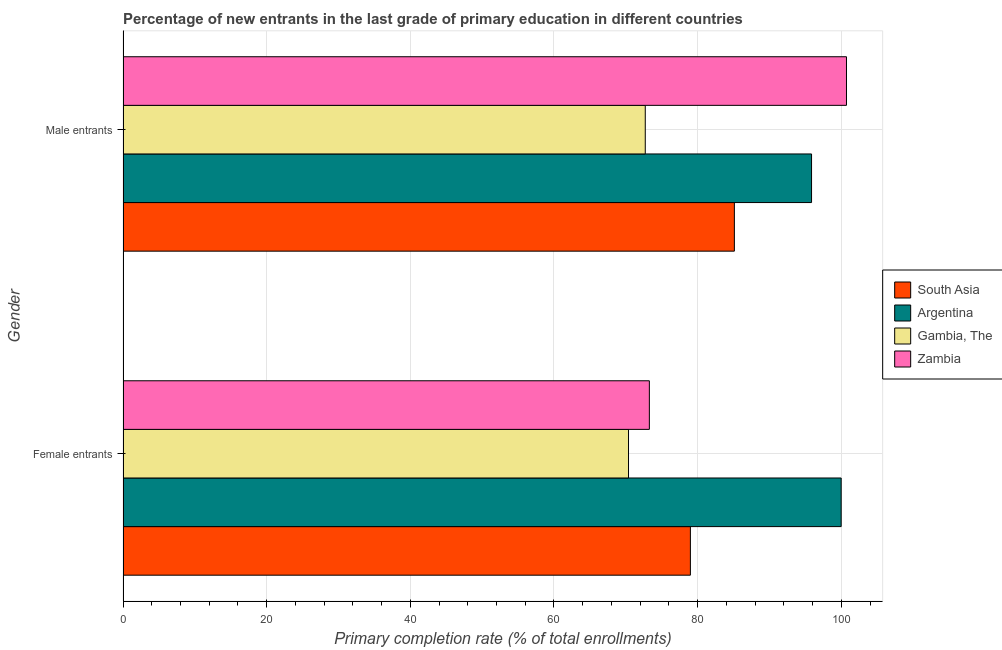How many different coloured bars are there?
Your answer should be compact. 4. How many bars are there on the 2nd tick from the top?
Provide a short and direct response. 4. How many bars are there on the 2nd tick from the bottom?
Give a very brief answer. 4. What is the label of the 1st group of bars from the top?
Your answer should be very brief. Male entrants. What is the primary completion rate of male entrants in South Asia?
Your answer should be very brief. 85.12. Across all countries, what is the maximum primary completion rate of female entrants?
Provide a succinct answer. 99.98. Across all countries, what is the minimum primary completion rate of male entrants?
Your answer should be compact. 72.71. In which country was the primary completion rate of male entrants maximum?
Your answer should be compact. Zambia. In which country was the primary completion rate of female entrants minimum?
Make the answer very short. Gambia, The. What is the total primary completion rate of female entrants in the graph?
Provide a succinct answer. 322.63. What is the difference between the primary completion rate of female entrants in Gambia, The and that in Argentina?
Make the answer very short. -29.61. What is the difference between the primary completion rate of male entrants in South Asia and the primary completion rate of female entrants in Zambia?
Ensure brevity in your answer.  11.84. What is the average primary completion rate of female entrants per country?
Your response must be concise. 80.66. What is the difference between the primary completion rate of male entrants and primary completion rate of female entrants in South Asia?
Your answer should be very brief. 6.12. What is the ratio of the primary completion rate of male entrants in Gambia, The to that in South Asia?
Give a very brief answer. 0.85. In how many countries, is the primary completion rate of male entrants greater than the average primary completion rate of male entrants taken over all countries?
Your answer should be compact. 2. What does the 2nd bar from the top in Male entrants represents?
Your answer should be compact. Gambia, The. How many bars are there?
Provide a short and direct response. 8. Are all the bars in the graph horizontal?
Keep it short and to the point. Yes. Are the values on the major ticks of X-axis written in scientific E-notation?
Offer a terse response. No. Does the graph contain any zero values?
Provide a short and direct response. No. How many legend labels are there?
Give a very brief answer. 4. What is the title of the graph?
Ensure brevity in your answer.  Percentage of new entrants in the last grade of primary education in different countries. What is the label or title of the X-axis?
Provide a succinct answer. Primary completion rate (% of total enrollments). What is the Primary completion rate (% of total enrollments) in South Asia in Female entrants?
Ensure brevity in your answer.  78.99. What is the Primary completion rate (% of total enrollments) of Argentina in Female entrants?
Your response must be concise. 99.98. What is the Primary completion rate (% of total enrollments) in Gambia, The in Female entrants?
Your answer should be compact. 70.38. What is the Primary completion rate (% of total enrollments) in Zambia in Female entrants?
Your response must be concise. 73.28. What is the Primary completion rate (% of total enrollments) in South Asia in Male entrants?
Make the answer very short. 85.12. What is the Primary completion rate (% of total enrollments) of Argentina in Male entrants?
Ensure brevity in your answer.  95.86. What is the Primary completion rate (% of total enrollments) of Gambia, The in Male entrants?
Your response must be concise. 72.71. What is the Primary completion rate (% of total enrollments) of Zambia in Male entrants?
Your answer should be very brief. 100.72. Across all Gender, what is the maximum Primary completion rate (% of total enrollments) in South Asia?
Make the answer very short. 85.12. Across all Gender, what is the maximum Primary completion rate (% of total enrollments) of Argentina?
Provide a succinct answer. 99.98. Across all Gender, what is the maximum Primary completion rate (% of total enrollments) of Gambia, The?
Give a very brief answer. 72.71. Across all Gender, what is the maximum Primary completion rate (% of total enrollments) of Zambia?
Keep it short and to the point. 100.72. Across all Gender, what is the minimum Primary completion rate (% of total enrollments) of South Asia?
Give a very brief answer. 78.99. Across all Gender, what is the minimum Primary completion rate (% of total enrollments) of Argentina?
Make the answer very short. 95.86. Across all Gender, what is the minimum Primary completion rate (% of total enrollments) in Gambia, The?
Give a very brief answer. 70.38. Across all Gender, what is the minimum Primary completion rate (% of total enrollments) of Zambia?
Your answer should be compact. 73.28. What is the total Primary completion rate (% of total enrollments) in South Asia in the graph?
Your response must be concise. 164.11. What is the total Primary completion rate (% of total enrollments) in Argentina in the graph?
Provide a succinct answer. 195.84. What is the total Primary completion rate (% of total enrollments) in Gambia, The in the graph?
Ensure brevity in your answer.  143.09. What is the total Primary completion rate (% of total enrollments) in Zambia in the graph?
Your answer should be very brief. 174. What is the difference between the Primary completion rate (% of total enrollments) in South Asia in Female entrants and that in Male entrants?
Your answer should be compact. -6.12. What is the difference between the Primary completion rate (% of total enrollments) in Argentina in Female entrants and that in Male entrants?
Keep it short and to the point. 4.12. What is the difference between the Primary completion rate (% of total enrollments) of Gambia, The in Female entrants and that in Male entrants?
Your response must be concise. -2.33. What is the difference between the Primary completion rate (% of total enrollments) in Zambia in Female entrants and that in Male entrants?
Your answer should be very brief. -27.44. What is the difference between the Primary completion rate (% of total enrollments) of South Asia in Female entrants and the Primary completion rate (% of total enrollments) of Argentina in Male entrants?
Offer a very short reply. -16.87. What is the difference between the Primary completion rate (% of total enrollments) in South Asia in Female entrants and the Primary completion rate (% of total enrollments) in Gambia, The in Male entrants?
Offer a very short reply. 6.28. What is the difference between the Primary completion rate (% of total enrollments) in South Asia in Female entrants and the Primary completion rate (% of total enrollments) in Zambia in Male entrants?
Provide a short and direct response. -21.73. What is the difference between the Primary completion rate (% of total enrollments) of Argentina in Female entrants and the Primary completion rate (% of total enrollments) of Gambia, The in Male entrants?
Provide a short and direct response. 27.27. What is the difference between the Primary completion rate (% of total enrollments) in Argentina in Female entrants and the Primary completion rate (% of total enrollments) in Zambia in Male entrants?
Keep it short and to the point. -0.74. What is the difference between the Primary completion rate (% of total enrollments) in Gambia, The in Female entrants and the Primary completion rate (% of total enrollments) in Zambia in Male entrants?
Provide a succinct answer. -30.35. What is the average Primary completion rate (% of total enrollments) in South Asia per Gender?
Offer a very short reply. 82.05. What is the average Primary completion rate (% of total enrollments) in Argentina per Gender?
Your answer should be very brief. 97.92. What is the average Primary completion rate (% of total enrollments) of Gambia, The per Gender?
Make the answer very short. 71.54. What is the average Primary completion rate (% of total enrollments) of Zambia per Gender?
Your response must be concise. 87. What is the difference between the Primary completion rate (% of total enrollments) of South Asia and Primary completion rate (% of total enrollments) of Argentina in Female entrants?
Provide a short and direct response. -20.99. What is the difference between the Primary completion rate (% of total enrollments) in South Asia and Primary completion rate (% of total enrollments) in Gambia, The in Female entrants?
Offer a terse response. 8.61. What is the difference between the Primary completion rate (% of total enrollments) of South Asia and Primary completion rate (% of total enrollments) of Zambia in Female entrants?
Offer a very short reply. 5.71. What is the difference between the Primary completion rate (% of total enrollments) of Argentina and Primary completion rate (% of total enrollments) of Gambia, The in Female entrants?
Ensure brevity in your answer.  29.61. What is the difference between the Primary completion rate (% of total enrollments) in Argentina and Primary completion rate (% of total enrollments) in Zambia in Female entrants?
Make the answer very short. 26.7. What is the difference between the Primary completion rate (% of total enrollments) of Gambia, The and Primary completion rate (% of total enrollments) of Zambia in Female entrants?
Offer a very short reply. -2.9. What is the difference between the Primary completion rate (% of total enrollments) of South Asia and Primary completion rate (% of total enrollments) of Argentina in Male entrants?
Offer a terse response. -10.74. What is the difference between the Primary completion rate (% of total enrollments) of South Asia and Primary completion rate (% of total enrollments) of Gambia, The in Male entrants?
Provide a succinct answer. 12.41. What is the difference between the Primary completion rate (% of total enrollments) in South Asia and Primary completion rate (% of total enrollments) in Zambia in Male entrants?
Give a very brief answer. -15.61. What is the difference between the Primary completion rate (% of total enrollments) of Argentina and Primary completion rate (% of total enrollments) of Gambia, The in Male entrants?
Your answer should be compact. 23.15. What is the difference between the Primary completion rate (% of total enrollments) in Argentina and Primary completion rate (% of total enrollments) in Zambia in Male entrants?
Provide a succinct answer. -4.86. What is the difference between the Primary completion rate (% of total enrollments) in Gambia, The and Primary completion rate (% of total enrollments) in Zambia in Male entrants?
Provide a short and direct response. -28.01. What is the ratio of the Primary completion rate (% of total enrollments) in South Asia in Female entrants to that in Male entrants?
Provide a succinct answer. 0.93. What is the ratio of the Primary completion rate (% of total enrollments) of Argentina in Female entrants to that in Male entrants?
Make the answer very short. 1.04. What is the ratio of the Primary completion rate (% of total enrollments) in Gambia, The in Female entrants to that in Male entrants?
Offer a very short reply. 0.97. What is the ratio of the Primary completion rate (% of total enrollments) of Zambia in Female entrants to that in Male entrants?
Ensure brevity in your answer.  0.73. What is the difference between the highest and the second highest Primary completion rate (% of total enrollments) of South Asia?
Keep it short and to the point. 6.12. What is the difference between the highest and the second highest Primary completion rate (% of total enrollments) of Argentina?
Provide a short and direct response. 4.12. What is the difference between the highest and the second highest Primary completion rate (% of total enrollments) in Gambia, The?
Give a very brief answer. 2.33. What is the difference between the highest and the second highest Primary completion rate (% of total enrollments) of Zambia?
Offer a very short reply. 27.44. What is the difference between the highest and the lowest Primary completion rate (% of total enrollments) of South Asia?
Ensure brevity in your answer.  6.12. What is the difference between the highest and the lowest Primary completion rate (% of total enrollments) of Argentina?
Give a very brief answer. 4.12. What is the difference between the highest and the lowest Primary completion rate (% of total enrollments) in Gambia, The?
Ensure brevity in your answer.  2.33. What is the difference between the highest and the lowest Primary completion rate (% of total enrollments) in Zambia?
Ensure brevity in your answer.  27.44. 